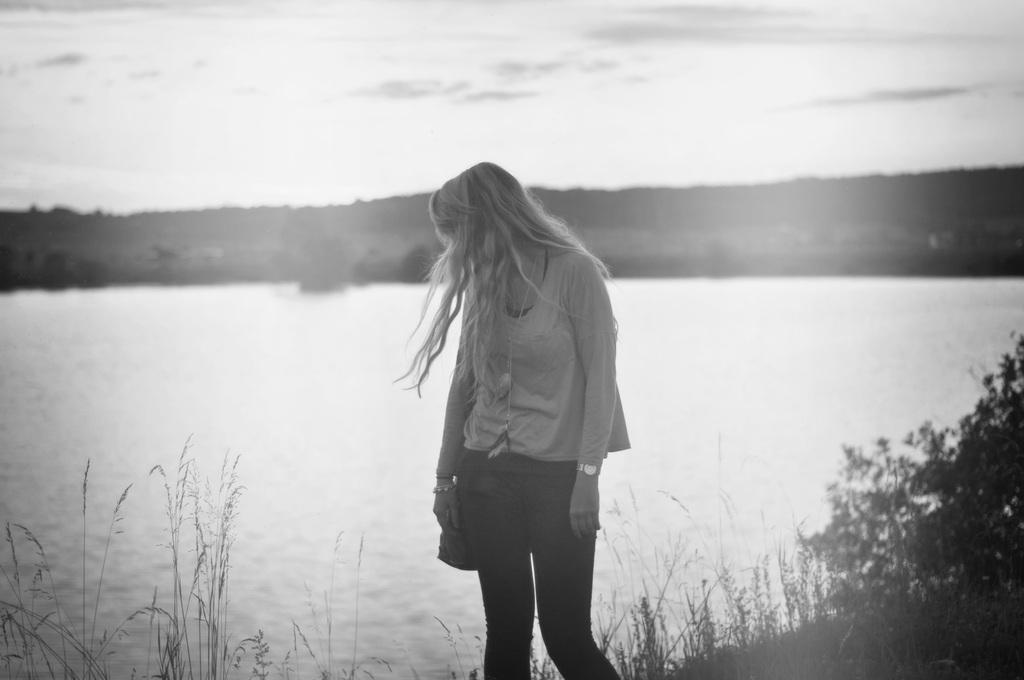What is the color scheme of the image? The image is black and white. Can you describe the person in the image? There is a person standing in the image. What can be seen in the background of the image? There is water, trees, and the sky visible in the background of the image. What type of zinc is being used to treat the disease in the image? There is no mention of zinc or disease in the image; it features a person standing in a black and white setting with water, trees, and the sky in the background. 